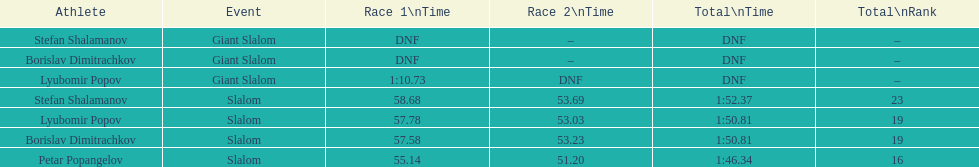Who came in the final position in the overall slalom event? Stefan Shalamanov. 